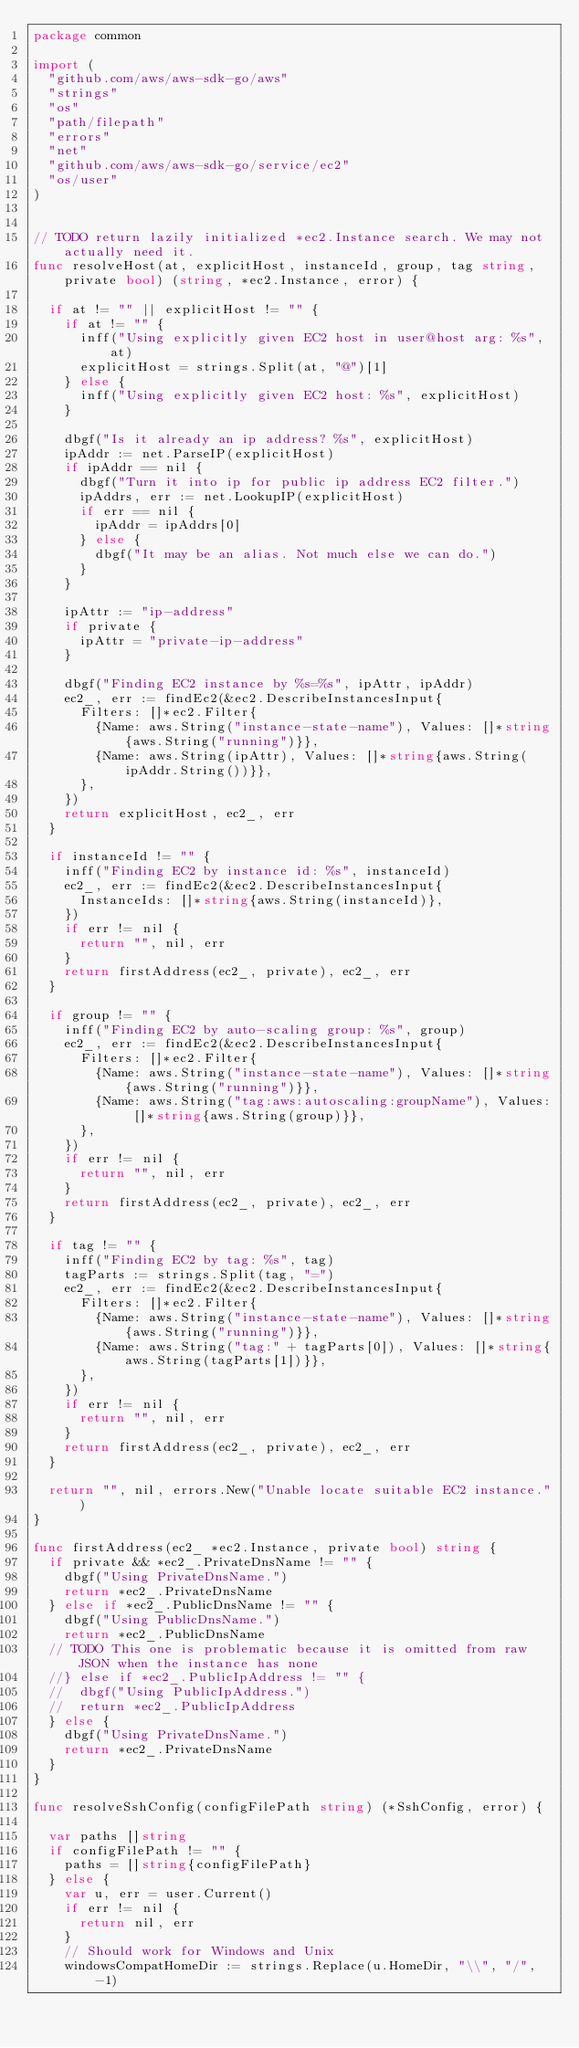Convert code to text. <code><loc_0><loc_0><loc_500><loc_500><_Go_>package common

import (
  "github.com/aws/aws-sdk-go/aws"
  "strings"
  "os"
  "path/filepath"
  "errors"
  "net"
  "github.com/aws/aws-sdk-go/service/ec2"
  "os/user"
)


// TODO return lazily initialized *ec2.Instance search. We may not actually need it.
func resolveHost(at, explicitHost, instanceId, group, tag string, private bool) (string, *ec2.Instance, error) {

  if at != "" || explicitHost != "" {
    if at != "" {
      inff("Using explicitly given EC2 host in user@host arg: %s", at)
      explicitHost = strings.Split(at, "@")[1]
    } else {
      inff("Using explicitly given EC2 host: %s", explicitHost)
    }

    dbgf("Is it already an ip address? %s", explicitHost)
    ipAddr := net.ParseIP(explicitHost)
    if ipAddr == nil {
      dbgf("Turn it into ip for public ip address EC2 filter.")
      ipAddrs, err := net.LookupIP(explicitHost)
      if err == nil {
        ipAddr = ipAddrs[0]
      } else {
        dbgf("It may be an alias. Not much else we can do.")
      }
    }

    ipAttr := "ip-address"
    if private {
      ipAttr = "private-ip-address"
    }

    dbgf("Finding EC2 instance by %s=%s", ipAttr, ipAddr)
    ec2_, err := findEc2(&ec2.DescribeInstancesInput{
      Filters: []*ec2.Filter{
        {Name: aws.String("instance-state-name"), Values: []*string{aws.String("running")}},
        {Name: aws.String(ipAttr), Values: []*string{aws.String(ipAddr.String())}},
      },
    })
    return explicitHost, ec2_, err
  }

  if instanceId != "" {
    inff("Finding EC2 by instance id: %s", instanceId)
    ec2_, err := findEc2(&ec2.DescribeInstancesInput{
      InstanceIds: []*string{aws.String(instanceId)},
    })
    if err != nil {
      return "", nil, err
    }
    return firstAddress(ec2_, private), ec2_, err
  }

  if group != "" {
    inff("Finding EC2 by auto-scaling group: %s", group)
    ec2_, err := findEc2(&ec2.DescribeInstancesInput{
      Filters: []*ec2.Filter{
        {Name: aws.String("instance-state-name"), Values: []*string{aws.String("running")}},
        {Name: aws.String("tag:aws:autoscaling:groupName"), Values: []*string{aws.String(group)}},
      },
    })
    if err != nil {
      return "", nil, err
    }
    return firstAddress(ec2_, private), ec2_, err
  }

  if tag != "" {
    inff("Finding EC2 by tag: %s", tag)
    tagParts := strings.Split(tag, "=")
    ec2_, err := findEc2(&ec2.DescribeInstancesInput{
      Filters: []*ec2.Filter{
        {Name: aws.String("instance-state-name"), Values: []*string{aws.String("running")}},
        {Name: aws.String("tag:" + tagParts[0]), Values: []*string{aws.String(tagParts[1])}},
      },
    })
    if err != nil {
      return "", nil, err
    }
    return firstAddress(ec2_, private), ec2_, err
  }

  return "", nil, errors.New("Unable locate suitable EC2 instance.")
}

func firstAddress(ec2_ *ec2.Instance, private bool) string {
  if private && *ec2_.PrivateDnsName != "" {
    dbgf("Using PrivateDnsName.")
    return *ec2_.PrivateDnsName
  } else if *ec2_.PublicDnsName != "" {
    dbgf("Using PublicDnsName.")
    return *ec2_.PublicDnsName
  // TODO This one is problematic because it is omitted from raw JSON when the instance has none
  //} else if *ec2_.PublicIpAddress != "" {
  //  dbgf("Using PublicIpAddress.")
  //  return *ec2_.PublicIpAddress
  } else {
    dbgf("Using PrivateDnsName.")
    return *ec2_.PrivateDnsName
  }
}

func resolveSshConfig(configFilePath string) (*SshConfig, error) {

  var paths []string
  if configFilePath != "" {
    paths = []string{configFilePath}
  } else {
    var u, err = user.Current()
    if err != nil {
      return nil, err
    }
    // Should work for Windows and Unix
    windowsCompatHomeDir := strings.Replace(u.HomeDir, "\\", "/", -1)</code> 